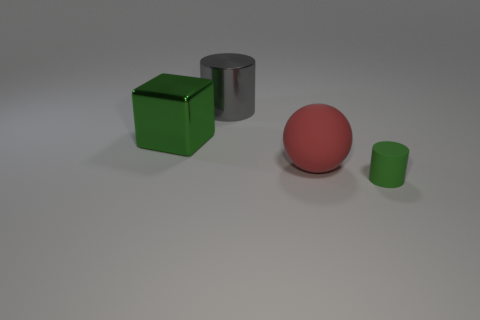There is a green matte object that is the same shape as the gray thing; what size is it?
Give a very brief answer. Small. What color is the other metallic thing that is the same shape as the small green thing?
Provide a short and direct response. Gray. Is there a red matte cylinder?
Keep it short and to the point. No. How many other things are there of the same size as the green cylinder?
Offer a very short reply. 0. Is the ball made of the same material as the cylinder behind the small matte thing?
Provide a succinct answer. No. Are there the same number of large green cubes that are to the right of the tiny green rubber thing and cylinders in front of the big ball?
Give a very brief answer. No. What material is the big gray cylinder?
Offer a very short reply. Metal. There is a block that is the same size as the red object; what is its color?
Offer a very short reply. Green. There is a shiny thing left of the metal cylinder; are there any large red matte spheres that are in front of it?
Give a very brief answer. Yes. How many balls are tiny blue rubber objects or tiny objects?
Offer a terse response. 0. 